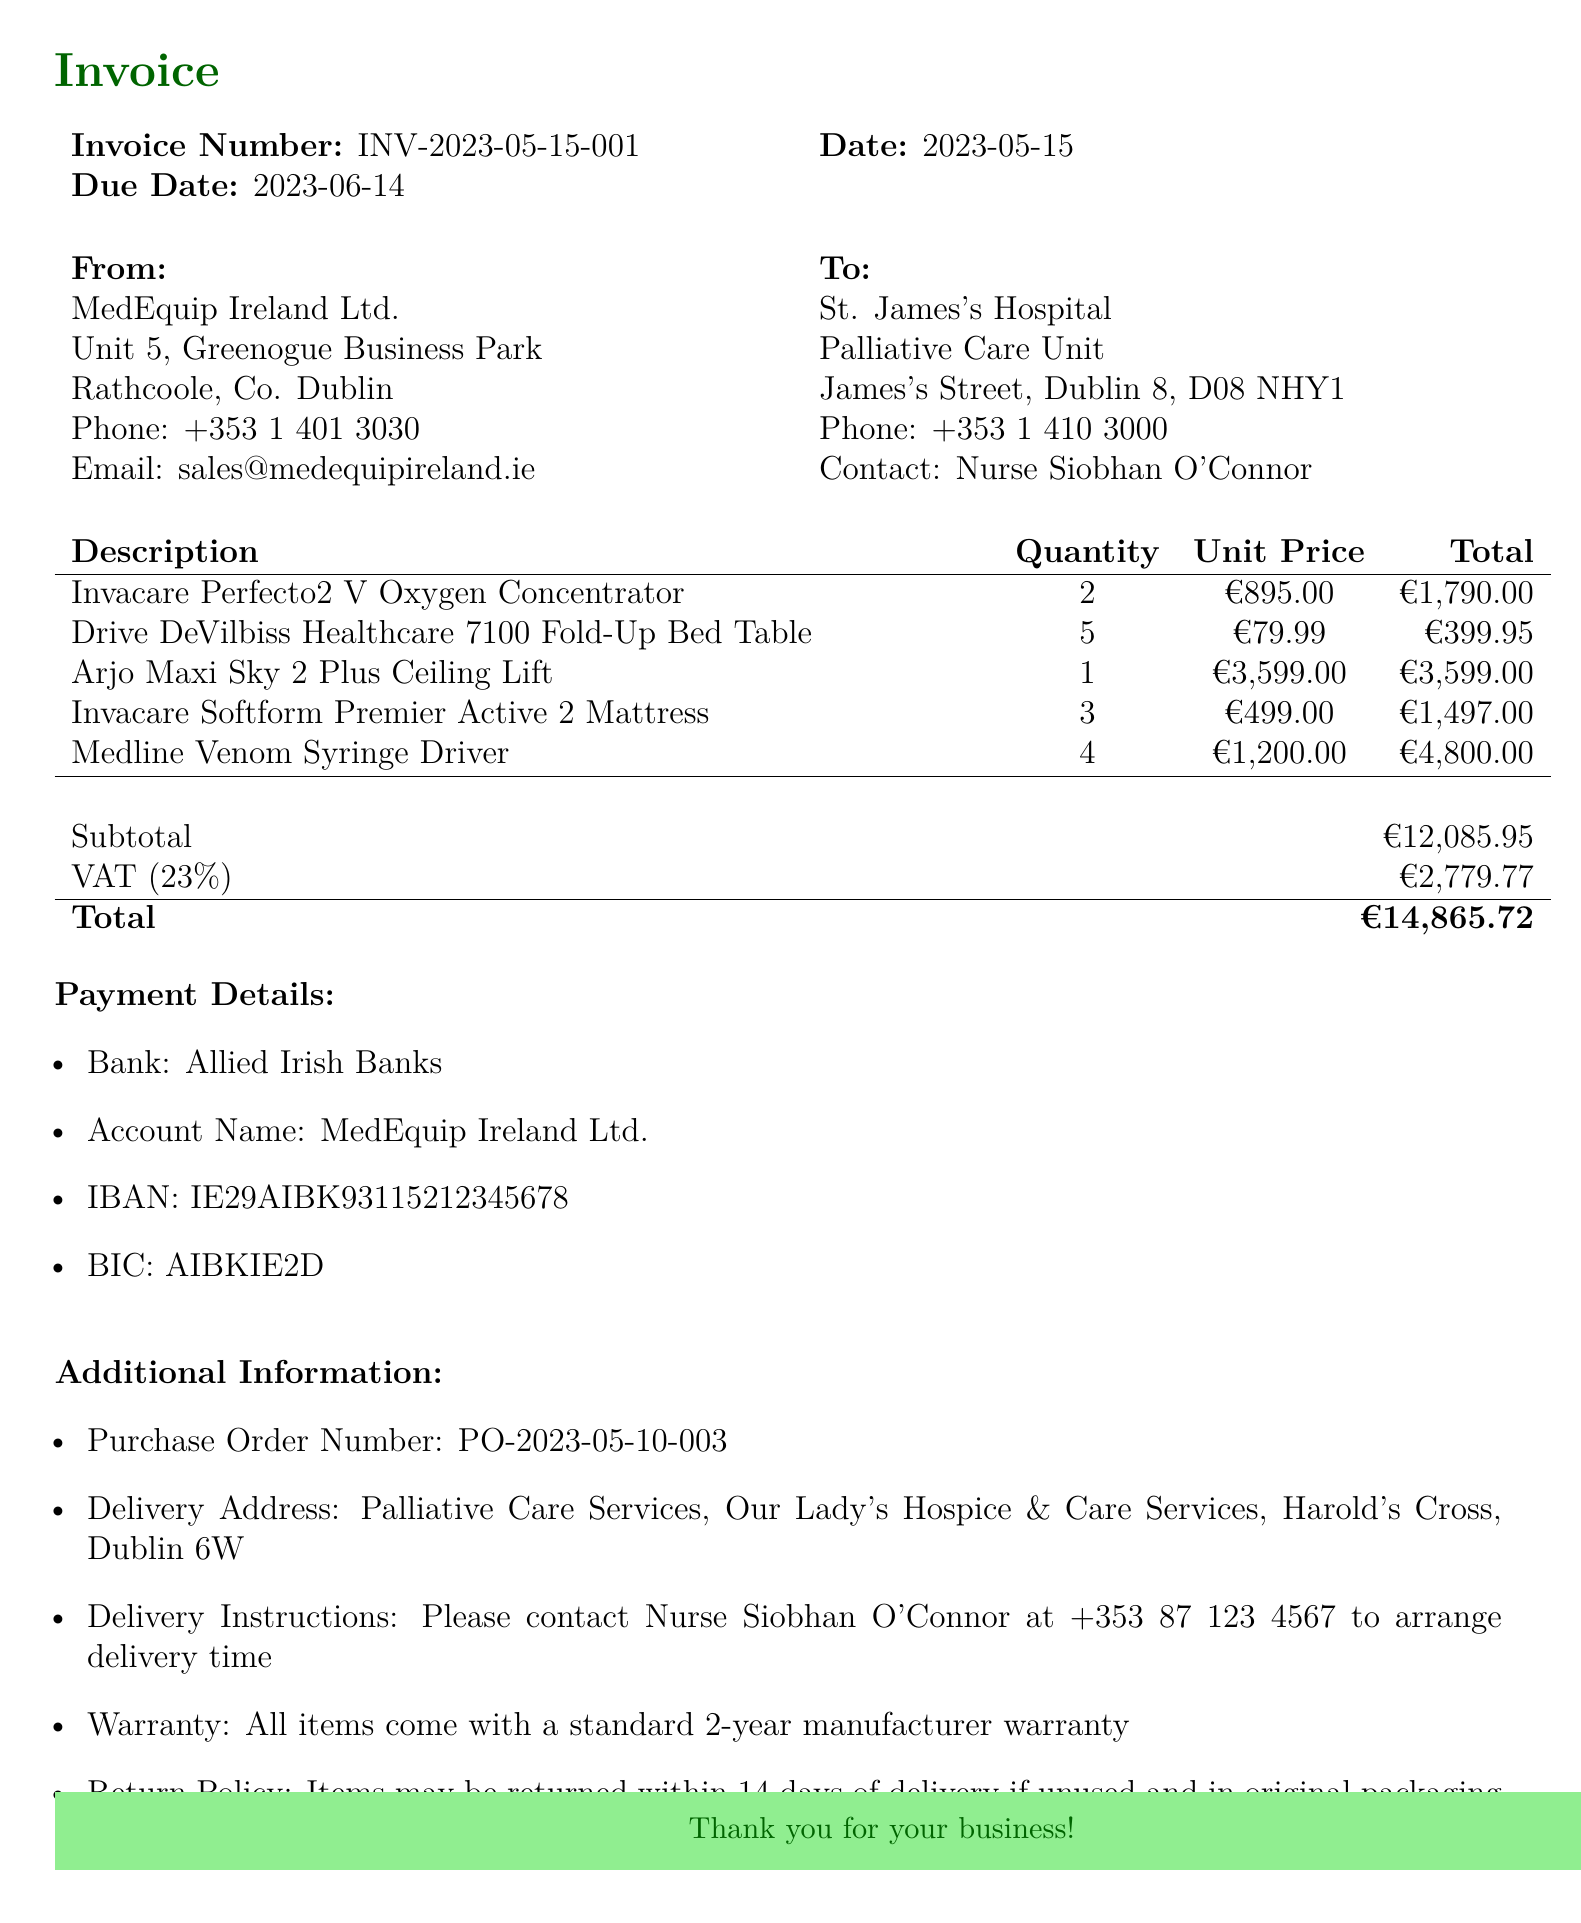What is the invoice number? The invoice number is a specific identifier for the transaction and is stated in the document.
Answer: INV-2023-05-15-001 What is the due date for the invoice? The due date indicates when the payment must be made by the customer, which is specified in the document.
Answer: 2023-06-14 Who is the contact person at St. James's Hospital? The contact person is mentioned in the customer information section and indicates who to communicate with regarding the invoice.
Answer: Nurse Siobhan O'Connor How many Invacare Perfecto2 V Oxygen Concentrators were purchased? The quantity is detailed under the items section and shows how many of that specific item were ordered.
Answer: 2 What is the total amount due on the invoice? The total amount due is the final sum including subtotals and VAT, specified in the document.
Answer: €14,865.72 What warranty is provided for the purchased items? The warranty information states the coverage included for the products purchased, as noted in the additional information section.
Answer: 2-year manufacturer warranty What delivery address is provided for the order? The delivery address is specified to indicate where the items should be delivered as per the customer’s instruction.
Answer: Palliative Care Services, Our Lady's Hospice & Care Services, Harold's Cross, Dublin 6W What is the VAT rate applied to this invoice? The VAT rate is mentioned in relation to the total price, indicating how much tax is added to the subtotal.
Answer: 23% How many Drive DeVilbiss Healthcare 7100 Fold-Up Bed Tables are there? The quantity signifies how many of that particular item were included in this transaction.
Answer: 5 